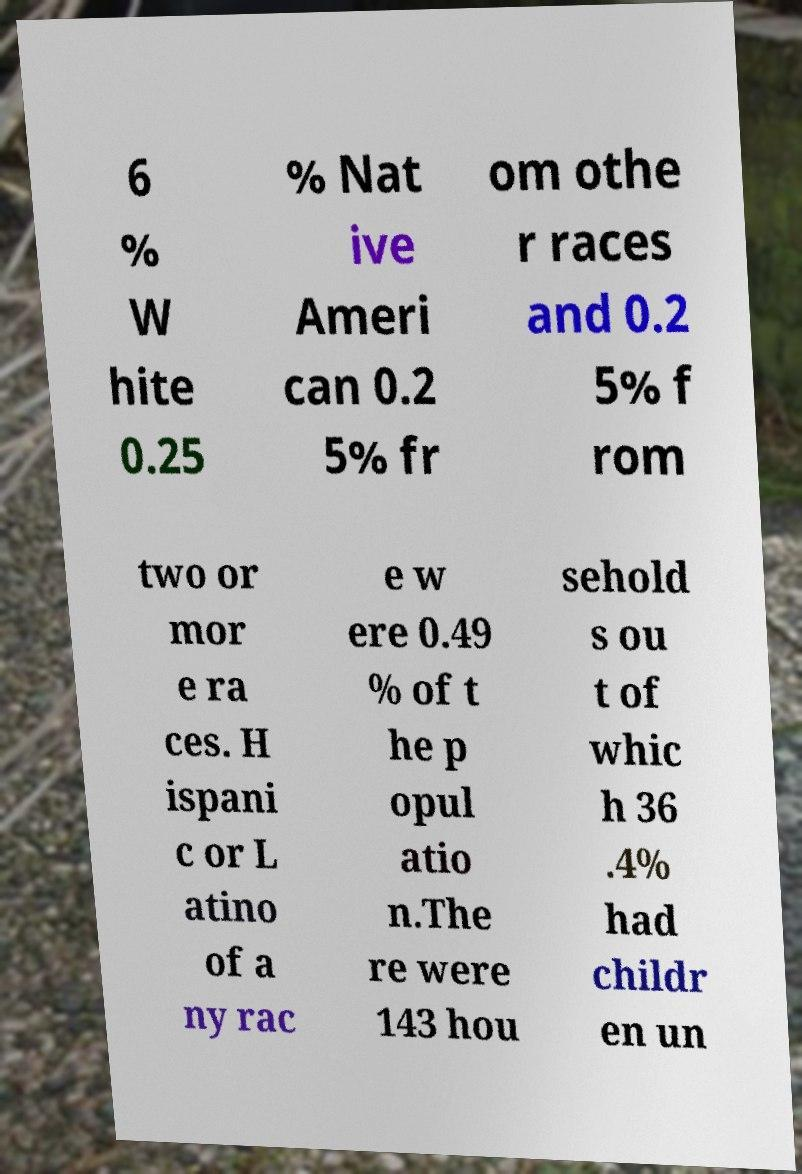There's text embedded in this image that I need extracted. Can you transcribe it verbatim? 6 % W hite 0.25 % Nat ive Ameri can 0.2 5% fr om othe r races and 0.2 5% f rom two or mor e ra ces. H ispani c or L atino of a ny rac e w ere 0.49 % of t he p opul atio n.The re were 143 hou sehold s ou t of whic h 36 .4% had childr en un 